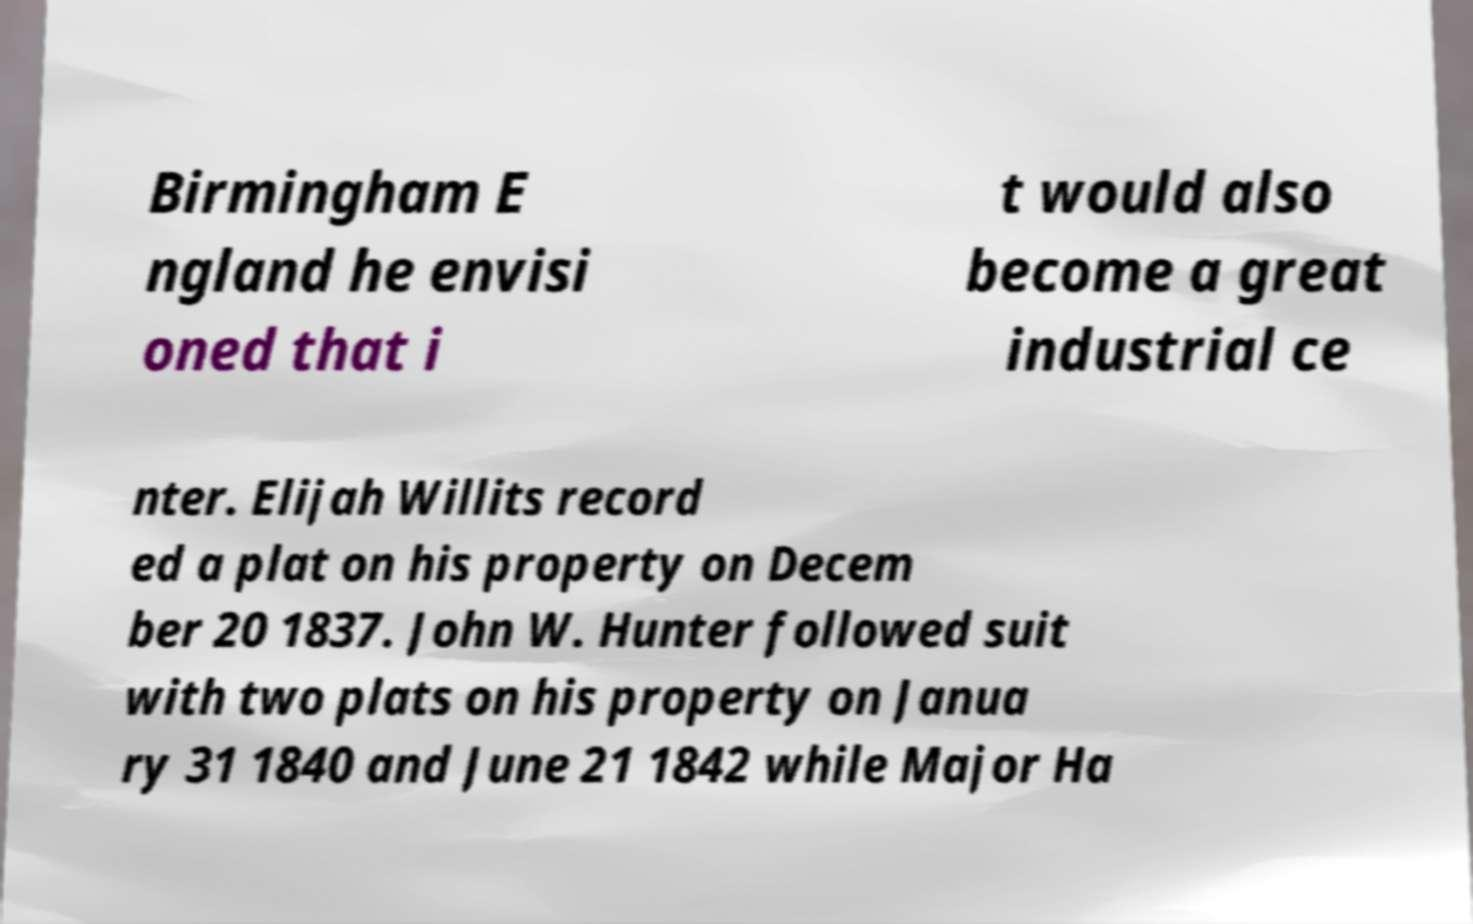For documentation purposes, I need the text within this image transcribed. Could you provide that? Birmingham E ngland he envisi oned that i t would also become a great industrial ce nter. Elijah Willits record ed a plat on his property on Decem ber 20 1837. John W. Hunter followed suit with two plats on his property on Janua ry 31 1840 and June 21 1842 while Major Ha 